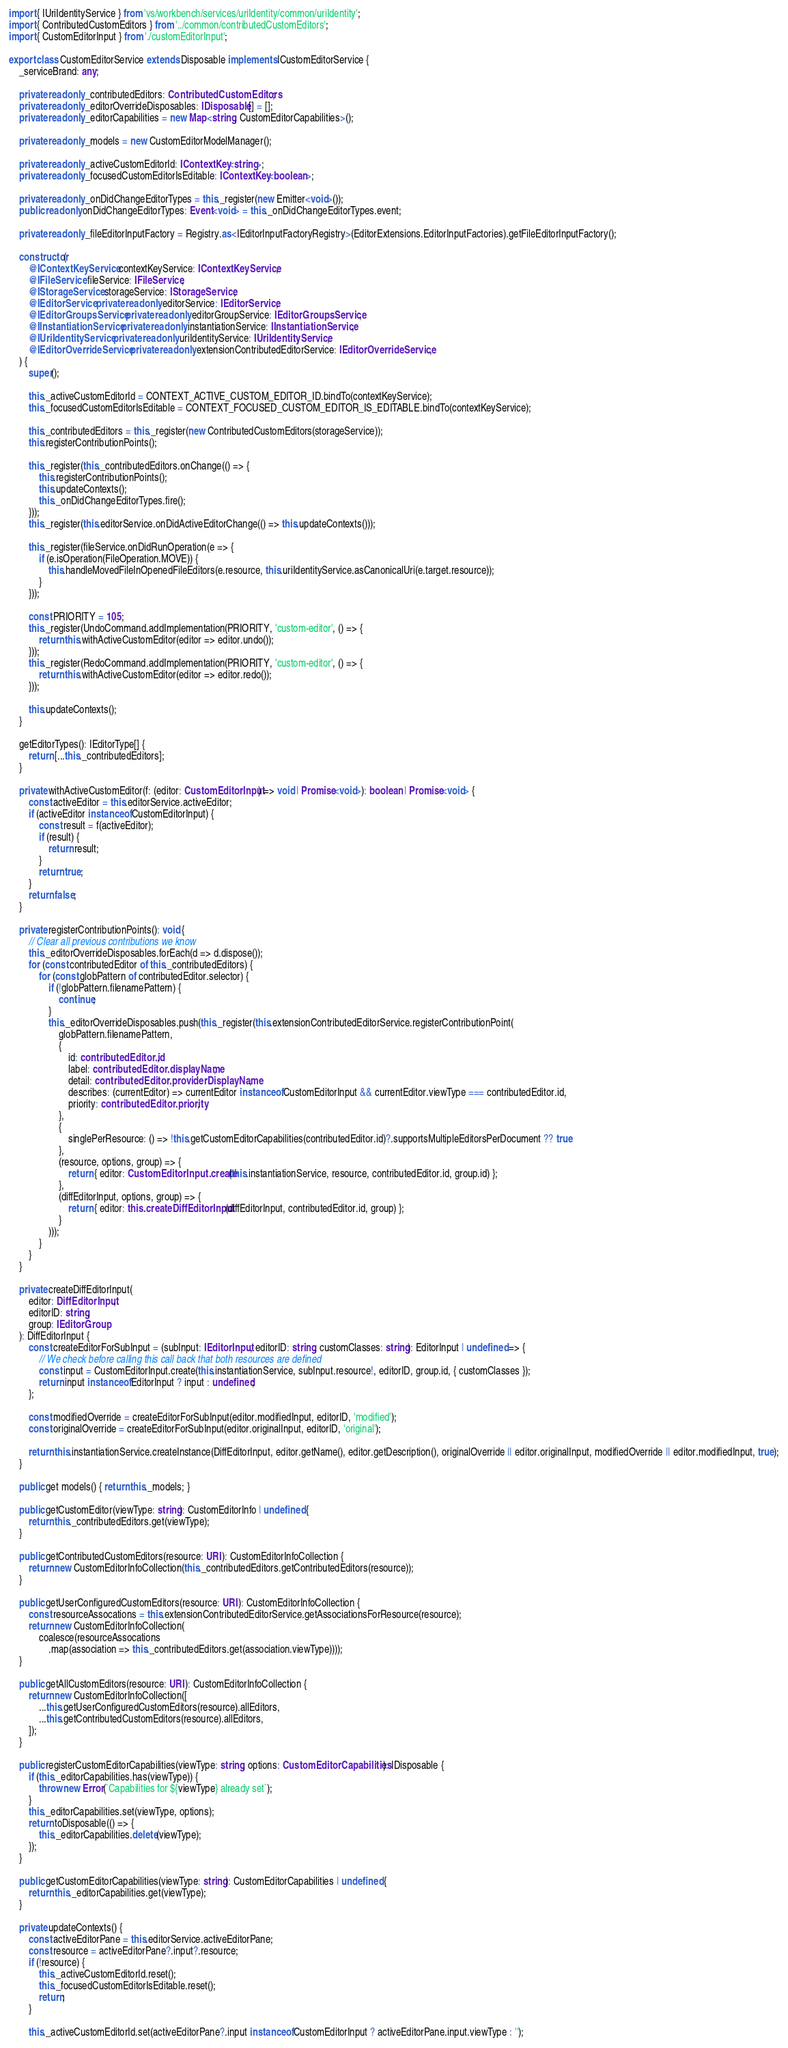Convert code to text. <code><loc_0><loc_0><loc_500><loc_500><_TypeScript_>import { IUriIdentityService } from 'vs/workbench/services/uriIdentity/common/uriIdentity';
import { ContributedCustomEditors } from '../common/contributedCustomEditors';
import { CustomEditorInput } from './customEditorInput';

export class CustomEditorService extends Disposable implements ICustomEditorService {
	_serviceBrand: any;

	private readonly _contributedEditors: ContributedCustomEditors;
	private readonly _editorOverrideDisposables: IDisposable[] = [];
	private readonly _editorCapabilities = new Map<string, CustomEditorCapabilities>();

	private readonly _models = new CustomEditorModelManager();

	private readonly _activeCustomEditorId: IContextKey<string>;
	private readonly _focusedCustomEditorIsEditable: IContextKey<boolean>;

	private readonly _onDidChangeEditorTypes = this._register(new Emitter<void>());
	public readonly onDidChangeEditorTypes: Event<void> = this._onDidChangeEditorTypes.event;

	private readonly _fileEditorInputFactory = Registry.as<IEditorInputFactoryRegistry>(EditorExtensions.EditorInputFactories).getFileEditorInputFactory();

	constructor(
		@IContextKeyService contextKeyService: IContextKeyService,
		@IFileService fileService: IFileService,
		@IStorageService storageService: IStorageService,
		@IEditorService private readonly editorService: IEditorService,
		@IEditorGroupsService private readonly editorGroupService: IEditorGroupsService,
		@IInstantiationService private readonly instantiationService: IInstantiationService,
		@IUriIdentityService private readonly uriIdentityService: IUriIdentityService,
		@IEditorOverrideService private readonly extensionContributedEditorService: IEditorOverrideService,
	) {
		super();

		this._activeCustomEditorId = CONTEXT_ACTIVE_CUSTOM_EDITOR_ID.bindTo(contextKeyService);
		this._focusedCustomEditorIsEditable = CONTEXT_FOCUSED_CUSTOM_EDITOR_IS_EDITABLE.bindTo(contextKeyService);

		this._contributedEditors = this._register(new ContributedCustomEditors(storageService));
		this.registerContributionPoints();

		this._register(this._contributedEditors.onChange(() => {
			this.registerContributionPoints();
			this.updateContexts();
			this._onDidChangeEditorTypes.fire();
		}));
		this._register(this.editorService.onDidActiveEditorChange(() => this.updateContexts()));

		this._register(fileService.onDidRunOperation(e => {
			if (e.isOperation(FileOperation.MOVE)) {
				this.handleMovedFileInOpenedFileEditors(e.resource, this.uriIdentityService.asCanonicalUri(e.target.resource));
			}
		}));

		const PRIORITY = 105;
		this._register(UndoCommand.addImplementation(PRIORITY, 'custom-editor', () => {
			return this.withActiveCustomEditor(editor => editor.undo());
		}));
		this._register(RedoCommand.addImplementation(PRIORITY, 'custom-editor', () => {
			return this.withActiveCustomEditor(editor => editor.redo());
		}));

		this.updateContexts();
	}

	getEditorTypes(): IEditorType[] {
		return [...this._contributedEditors];
	}

	private withActiveCustomEditor(f: (editor: CustomEditorInput) => void | Promise<void>): boolean | Promise<void> {
		const activeEditor = this.editorService.activeEditor;
		if (activeEditor instanceof CustomEditorInput) {
			const result = f(activeEditor);
			if (result) {
				return result;
			}
			return true;
		}
		return false;
	}

	private registerContributionPoints(): void {
		// Clear all previous contributions we know
		this._editorOverrideDisposables.forEach(d => d.dispose());
		for (const contributedEditor of this._contributedEditors) {
			for (const globPattern of contributedEditor.selector) {
				if (!globPattern.filenamePattern) {
					continue;
				}
				this._editorOverrideDisposables.push(this._register(this.extensionContributedEditorService.registerContributionPoint(
					globPattern.filenamePattern,
					{
						id: contributedEditor.id,
						label: contributedEditor.displayName,
						detail: contributedEditor.providerDisplayName,
						describes: (currentEditor) => currentEditor instanceof CustomEditorInput && currentEditor.viewType === contributedEditor.id,
						priority: contributedEditor.priority,
					},
					{
						singlePerResource: () => !this.getCustomEditorCapabilities(contributedEditor.id)?.supportsMultipleEditorsPerDocument ?? true
					},
					(resource, options, group) => {
						return { editor: CustomEditorInput.create(this.instantiationService, resource, contributedEditor.id, group.id) };
					},
					(diffEditorInput, options, group) => {
						return { editor: this.createDiffEditorInput(diffEditorInput, contributedEditor.id, group) };
					}
				)));
			}
		}
	}

	private createDiffEditorInput(
		editor: DiffEditorInput,
		editorID: string,
		group: IEditorGroup
	): DiffEditorInput {
		const createEditorForSubInput = (subInput: IEditorInput, editorID: string, customClasses: string): EditorInput | undefined => {
			// We check before calling this call back that both resources are defined
			const input = CustomEditorInput.create(this.instantiationService, subInput.resource!, editorID, group.id, { customClasses });
			return input instanceof EditorInput ? input : undefined;
		};

		const modifiedOverride = createEditorForSubInput(editor.modifiedInput, editorID, 'modified');
		const originalOverride = createEditorForSubInput(editor.originalInput, editorID, 'original');

		return this.instantiationService.createInstance(DiffEditorInput, editor.getName(), editor.getDescription(), originalOverride || editor.originalInput, modifiedOverride || editor.modifiedInput, true);
	}

	public get models() { return this._models; }

	public getCustomEditor(viewType: string): CustomEditorInfo | undefined {
		return this._contributedEditors.get(viewType);
	}

	public getContributedCustomEditors(resource: URI): CustomEditorInfoCollection {
		return new CustomEditorInfoCollection(this._contributedEditors.getContributedEditors(resource));
	}

	public getUserConfiguredCustomEditors(resource: URI): CustomEditorInfoCollection {
		const resourceAssocations = this.extensionContributedEditorService.getAssociationsForResource(resource);
		return new CustomEditorInfoCollection(
			coalesce(resourceAssocations
				.map(association => this._contributedEditors.get(association.viewType))));
	}

	public getAllCustomEditors(resource: URI): CustomEditorInfoCollection {
		return new CustomEditorInfoCollection([
			...this.getUserConfiguredCustomEditors(resource).allEditors,
			...this.getContributedCustomEditors(resource).allEditors,
		]);
	}

	public registerCustomEditorCapabilities(viewType: string, options: CustomEditorCapabilities): IDisposable {
		if (this._editorCapabilities.has(viewType)) {
			throw new Error(`Capabilities for ${viewType} already set`);
		}
		this._editorCapabilities.set(viewType, options);
		return toDisposable(() => {
			this._editorCapabilities.delete(viewType);
		});
	}

	public getCustomEditorCapabilities(viewType: string): CustomEditorCapabilities | undefined {
		return this._editorCapabilities.get(viewType);
	}

	private updateContexts() {
		const activeEditorPane = this.editorService.activeEditorPane;
		const resource = activeEditorPane?.input?.resource;
		if (!resource) {
			this._activeCustomEditorId.reset();
			this._focusedCustomEditorIsEditable.reset();
			return;
		}

		this._activeCustomEditorId.set(activeEditorPane?.input instanceof CustomEditorInput ? activeEditorPane.input.viewType : '');</code> 